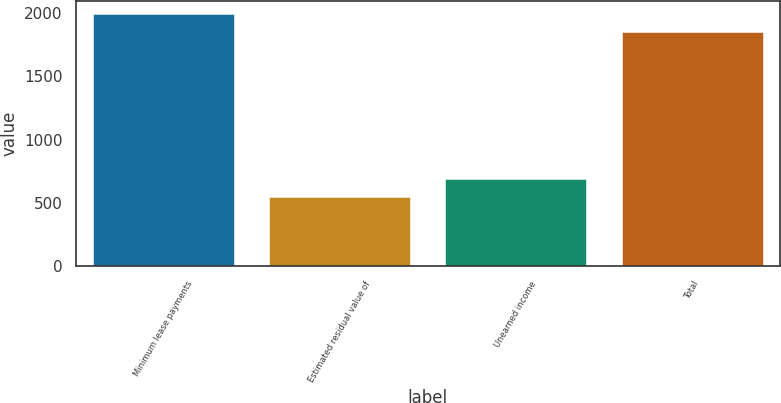Convert chart to OTSL. <chart><loc_0><loc_0><loc_500><loc_500><bar_chart><fcel>Minimum lease payments<fcel>Estimated residual value of<fcel>Unearned income<fcel>Total<nl><fcel>1994.3<fcel>544<fcel>688.3<fcel>1850<nl></chart> 